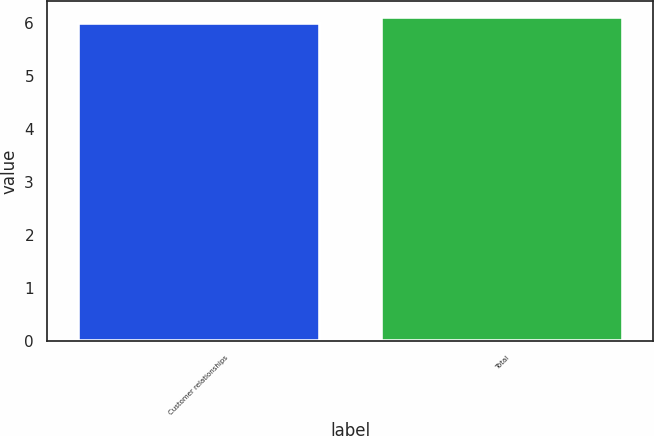Convert chart to OTSL. <chart><loc_0><loc_0><loc_500><loc_500><bar_chart><fcel>Customer relationships<fcel>Total<nl><fcel>6<fcel>6.1<nl></chart> 